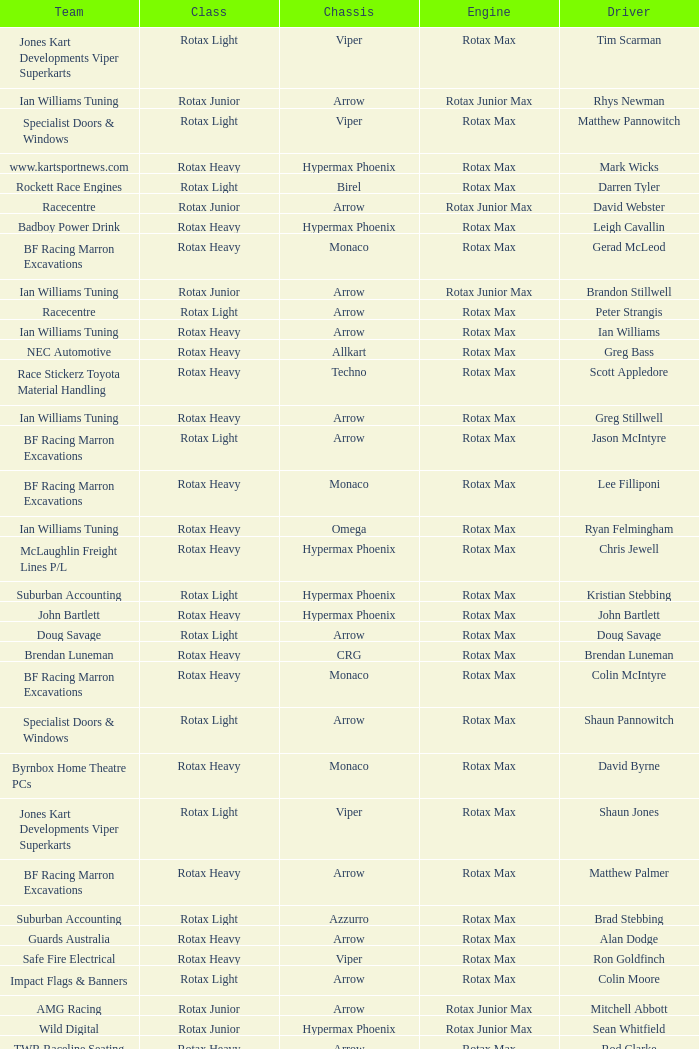Which team does Colin Moore drive for? Impact Flags & Banners. 